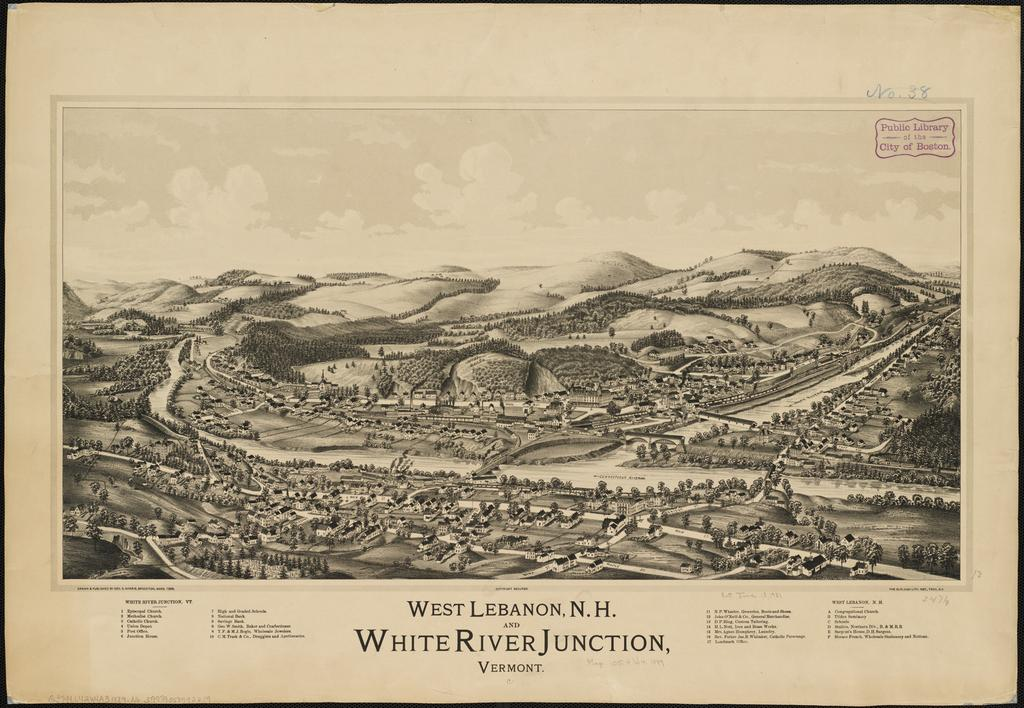Provide a one-sentence caption for the provided image. A old black and white city map of White River Junction. 